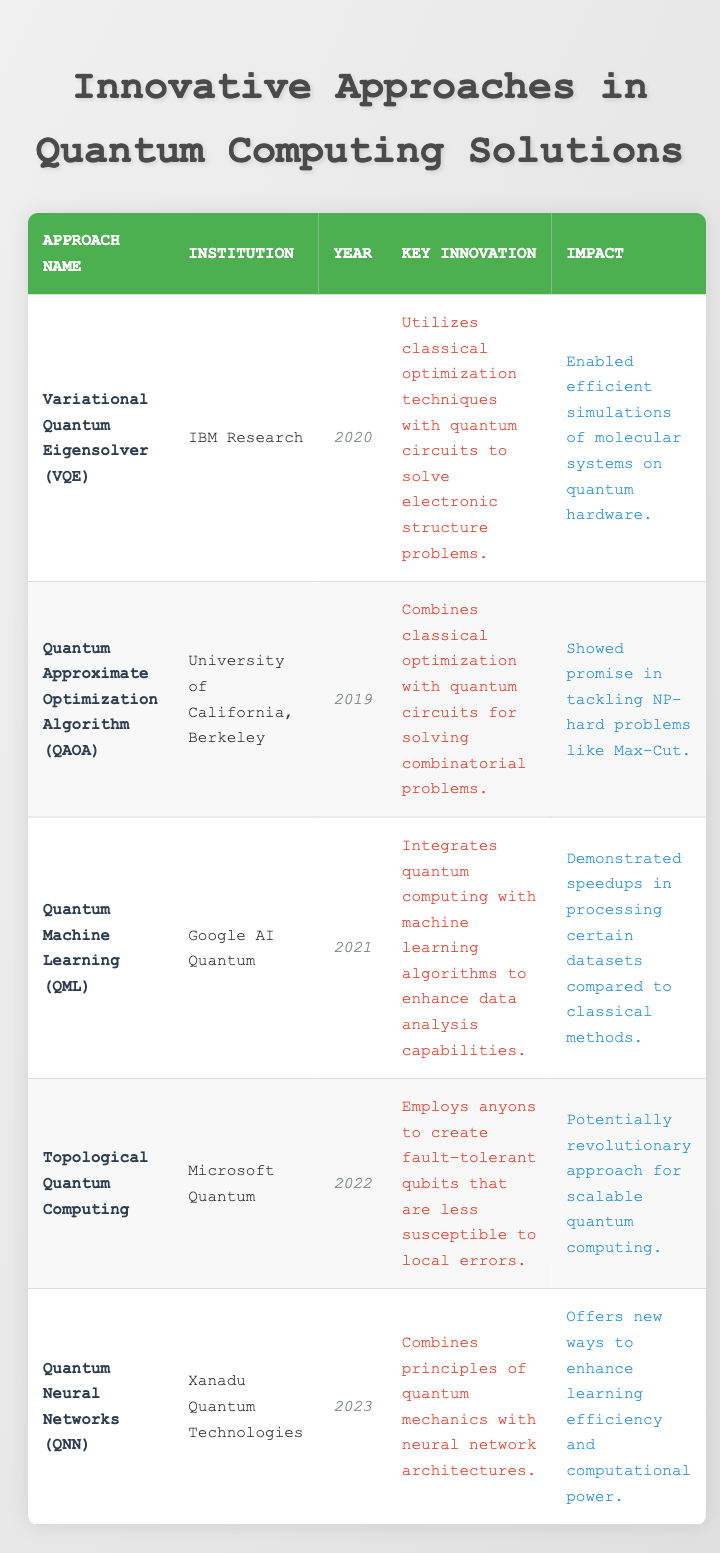What institution developed the Quantum Machine Learning approach? The table indicates that Quantum Machine Learning (QML) was developed by Google AI Quantum. This fact can be found in the corresponding row where QML is mentioned.
Answer: Google AI Quantum In what year was the Quantum Approximate Optimization Algorithm introduced? The approach of Quantum Approximate Optimization Algorithm (QAOA) was introduced in 2019, as shown in the respective row of the table.
Answer: 2019 Which approach was introduced first, Variational Quantum Eigensolver or Quantum Neural Networks? By comparing the years in the respective rows, Variational Quantum Eigensolver was introduced in 2020 while Quantum Neural Networks was introduced in 2023. Since 2020 is earlier than 2023, VQE was introduced first.
Answer: Variational Quantum Eigensolver Did IBM Research contribute to Quantum Computing Solutions that enable efficient simulations on quantum hardware? Yes, according to the table, IBM Research developed the Variational Quantum Eigensolver (VQE), which enabled efficient simulations of molecular systems on quantum hardware.
Answer: Yes What is the key innovation behind Topological Quantum Computing, and how does it impact quantum computing scalability? The key innovation behind Topological Quantum Computing is the use of anyons to create fault-tolerant qubits. This impact is significant as it could lead to a revolutionary approach for scalable quantum computing. The reasoning involves identifying both the innovation and its stated impact from the respective row.
Answer: Employs anyons to create fault-tolerant qubits; potential for scalable quantum computing What are the primary key innovations associated with the two most recent approaches in the table? The two most recent approaches listed are Quantum Neural Networks (QNN) and Topological Quantum Computing. QNN integrates quantum mechanics with neural network architectures, while Topological Quantum Computing employs anyons for fault-tolerant qubits. Therefore, we summarize the key innovations from both entries.
Answer: Integrates quantum mechanics with neural networks; employs anyons for fault-tolerant qubits 